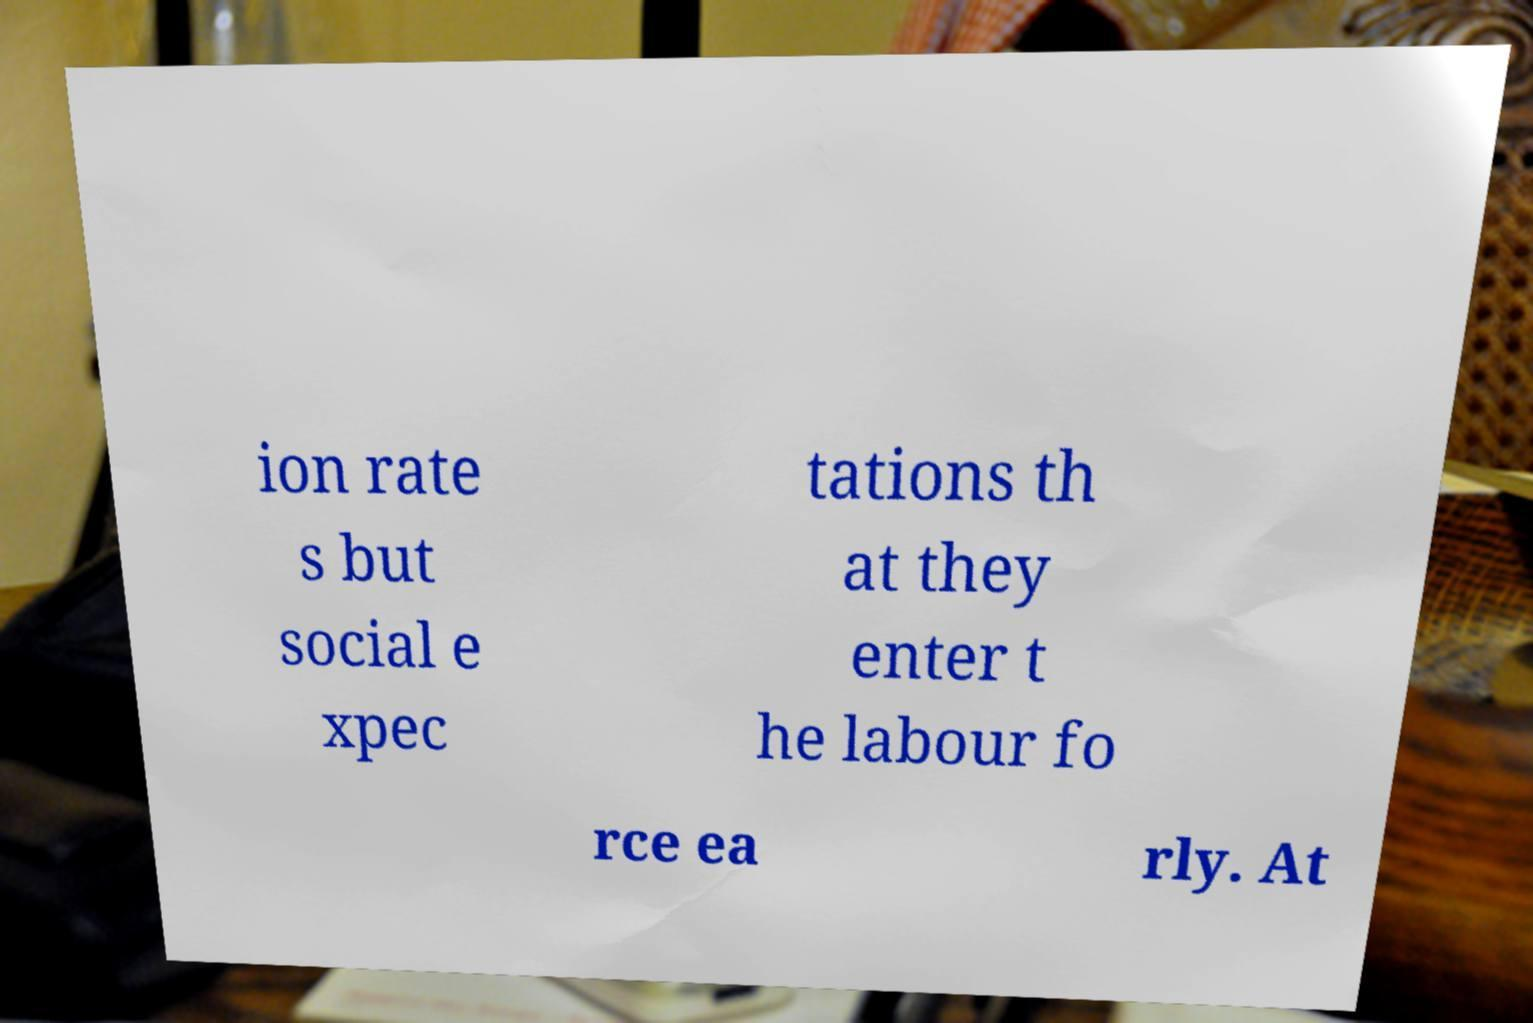What messages or text are displayed in this image? I need them in a readable, typed format. ion rate s but social e xpec tations th at they enter t he labour fo rce ea rly. At 